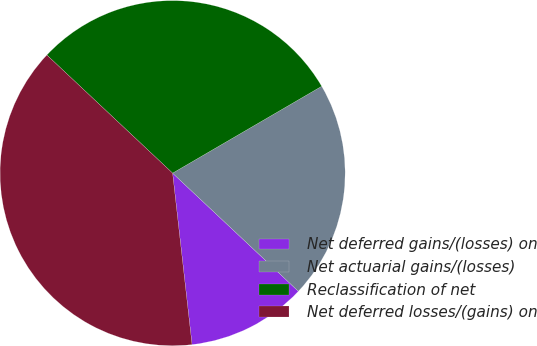Convert chart. <chart><loc_0><loc_0><loc_500><loc_500><pie_chart><fcel>Net deferred gains/(losses) on<fcel>Net actuarial gains/(losses)<fcel>Reclassification of net<fcel>Net deferred losses/(gains) on<nl><fcel>11.2%<fcel>20.4%<fcel>29.6%<fcel>38.8%<nl></chart> 